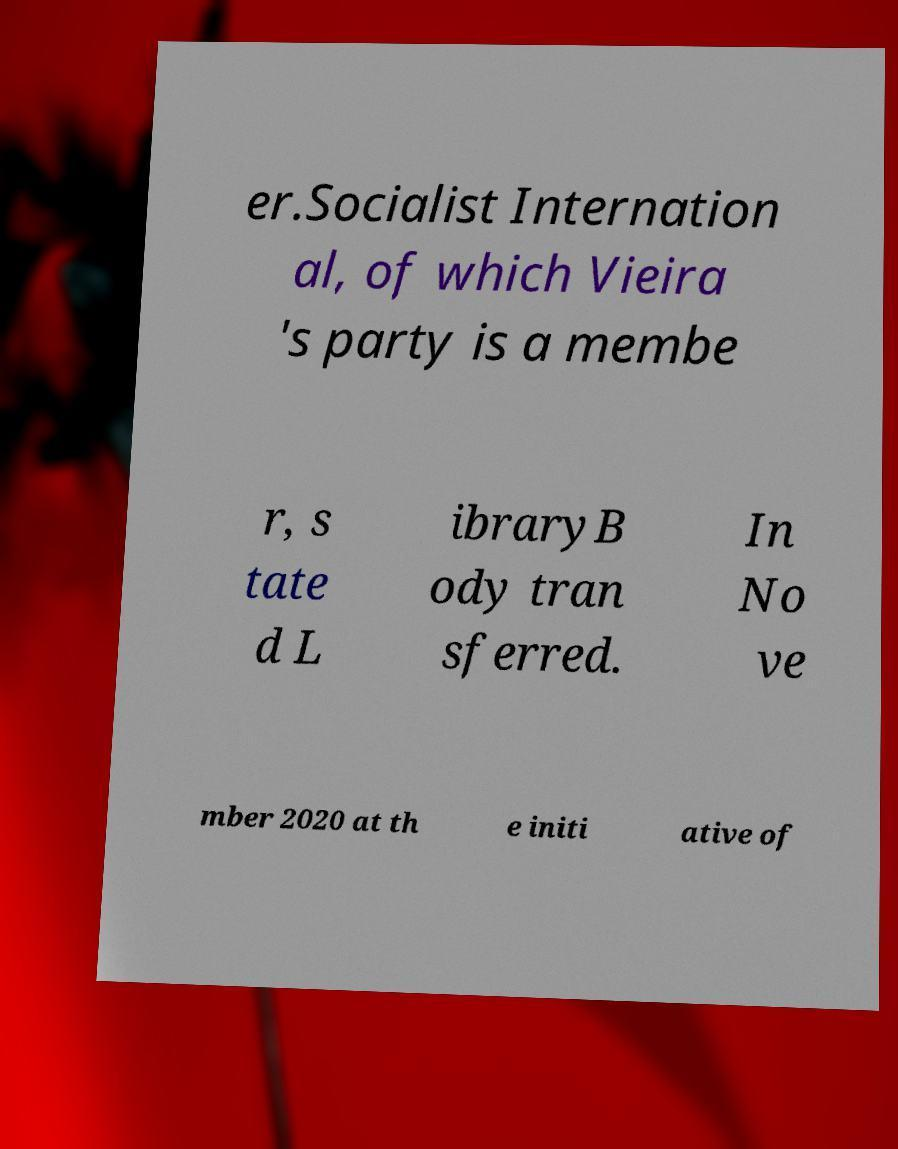There's text embedded in this image that I need extracted. Can you transcribe it verbatim? er.Socialist Internation al, of which Vieira 's party is a membe r, s tate d L ibraryB ody tran sferred. In No ve mber 2020 at th e initi ative of 